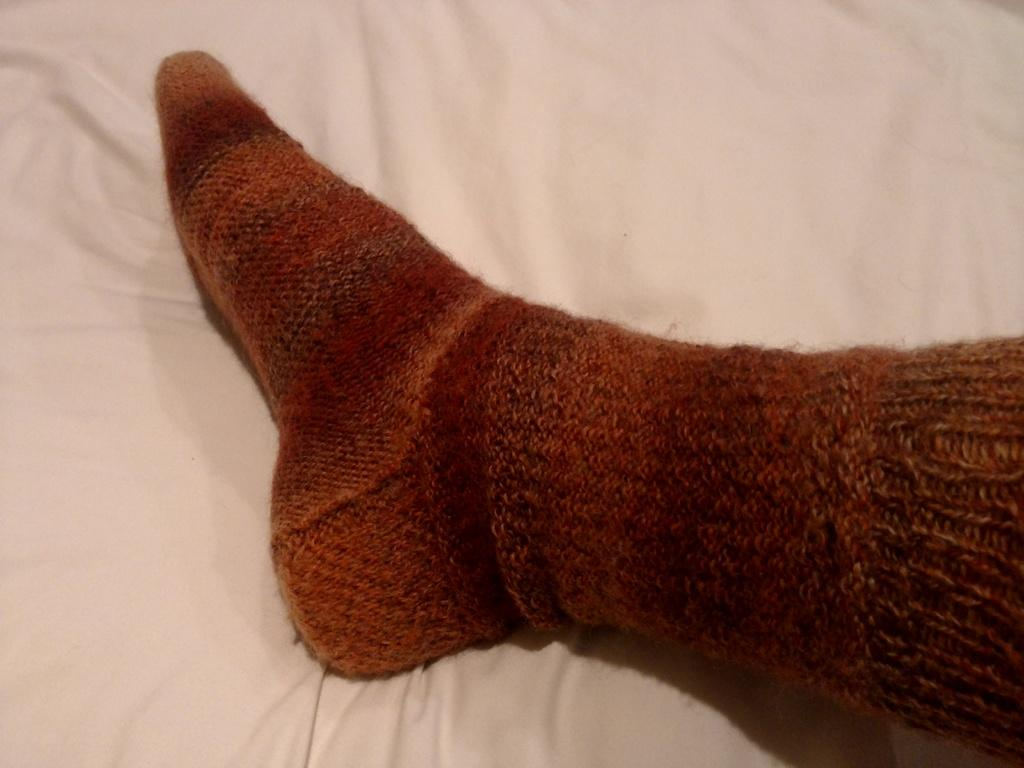What part of the person's body can be seen in the image? One person's leg is visible in the image. What type of clothing is the person wearing on their leg? The person is wearing socks. What can be seen in the background of the image? There is a blanket in the background of the image. What type of support can be seen holding up the sand in the image? There is no sand or support present in the image. 